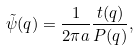<formula> <loc_0><loc_0><loc_500><loc_500>\tilde { \psi } ( q ) = \frac { 1 } { 2 \pi a } \frac { t ( q ) } { P ( q ) } ,</formula> 